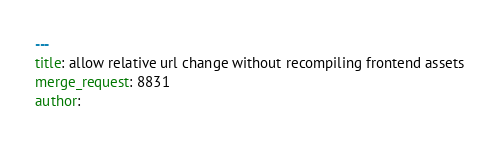Convert code to text. <code><loc_0><loc_0><loc_500><loc_500><_YAML_>---
title: allow relative url change without recompiling frontend assets
merge_request: 8831
author:
</code> 